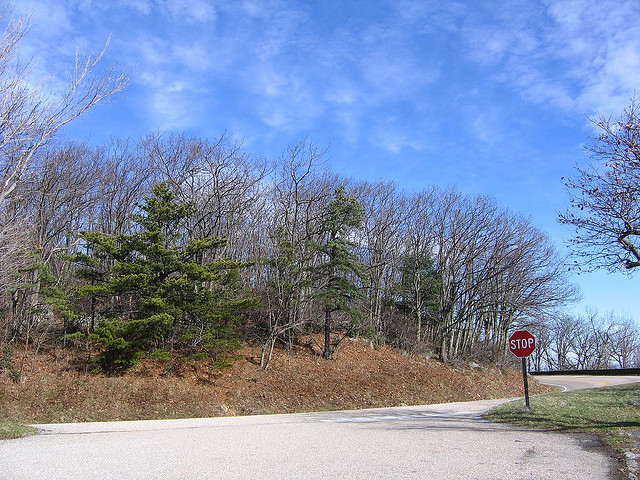What kind of forest is ahead? The forest ahead is deciduous, with many trees that shed their leaves annually, as evidenced by the absence of leaves on some trees and greenery on others. 